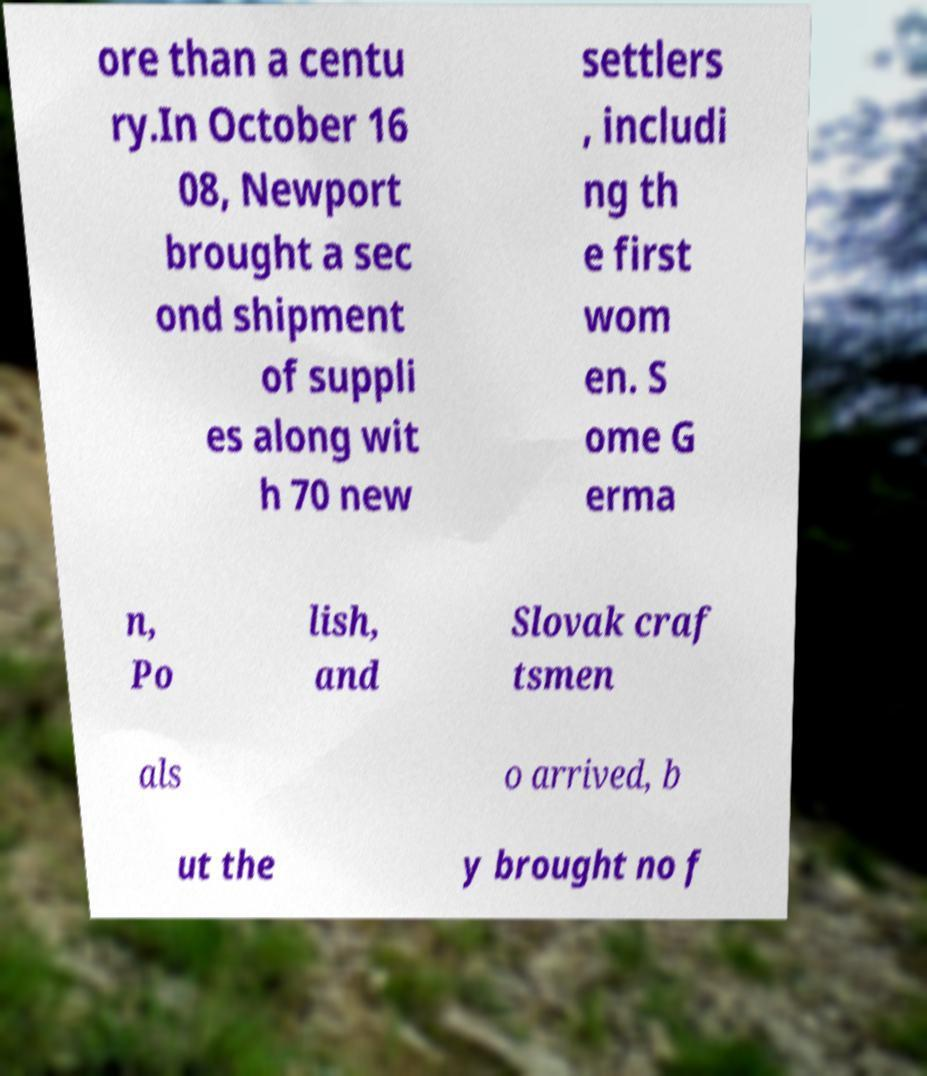Please read and relay the text visible in this image. What does it say? ore than a centu ry.In October 16 08, Newport brought a sec ond shipment of suppli es along wit h 70 new settlers , includi ng th e first wom en. S ome G erma n, Po lish, and Slovak craf tsmen als o arrived, b ut the y brought no f 